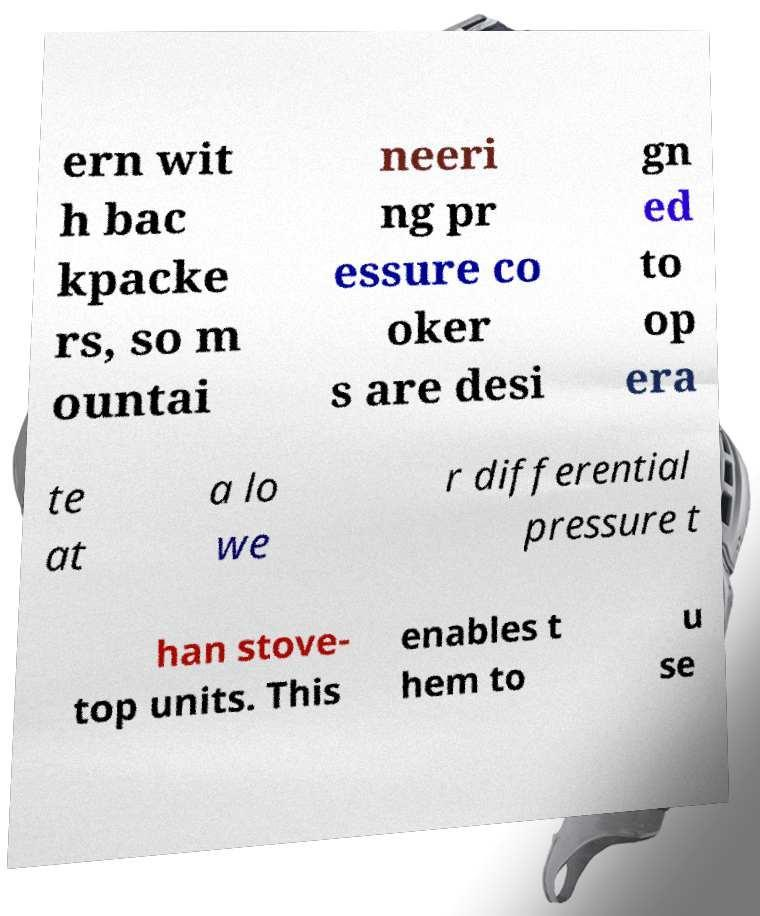I need the written content from this picture converted into text. Can you do that? ern wit h bac kpacke rs, so m ountai neeri ng pr essure co oker s are desi gn ed to op era te at a lo we r differential pressure t han stove- top units. This enables t hem to u se 